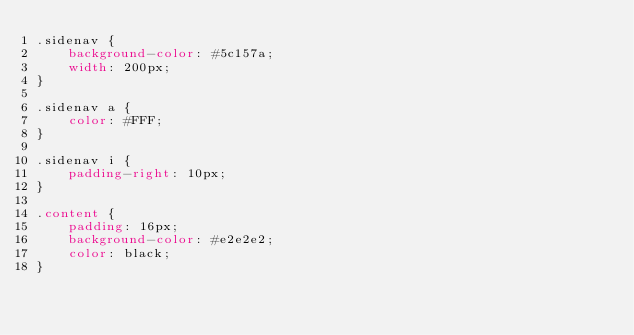Convert code to text. <code><loc_0><loc_0><loc_500><loc_500><_CSS_>.sidenav {
    background-color: #5c157a;
    width: 200px;
}

.sidenav a {
    color: #FFF;
}

.sidenav i {
    padding-right: 10px;
}

.content {
    padding: 16px;
    background-color: #e2e2e2;
    color: black;
}</code> 